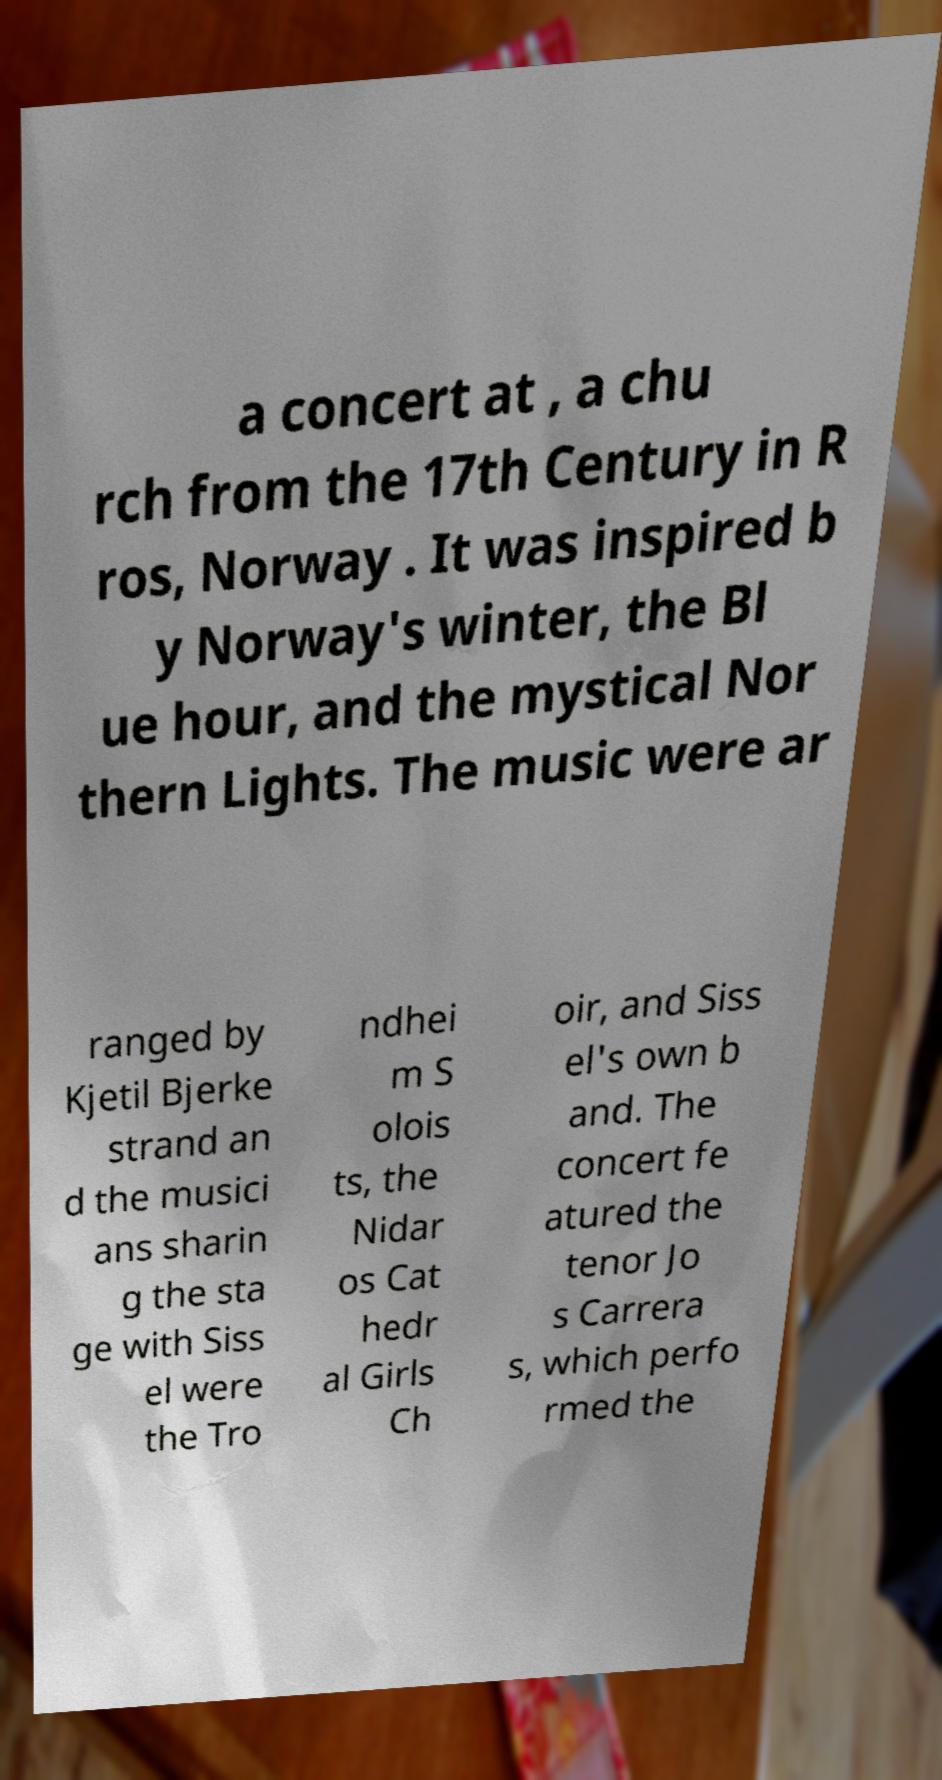I need the written content from this picture converted into text. Can you do that? a concert at , a chu rch from the 17th Century in R ros, Norway . It was inspired b y Norway's winter, the Bl ue hour, and the mystical Nor thern Lights. The music were ar ranged by Kjetil Bjerke strand an d the musici ans sharin g the sta ge with Siss el were the Tro ndhei m S olois ts, the Nidar os Cat hedr al Girls Ch oir, and Siss el's own b and. The concert fe atured the tenor Jo s Carrera s, which perfo rmed the 